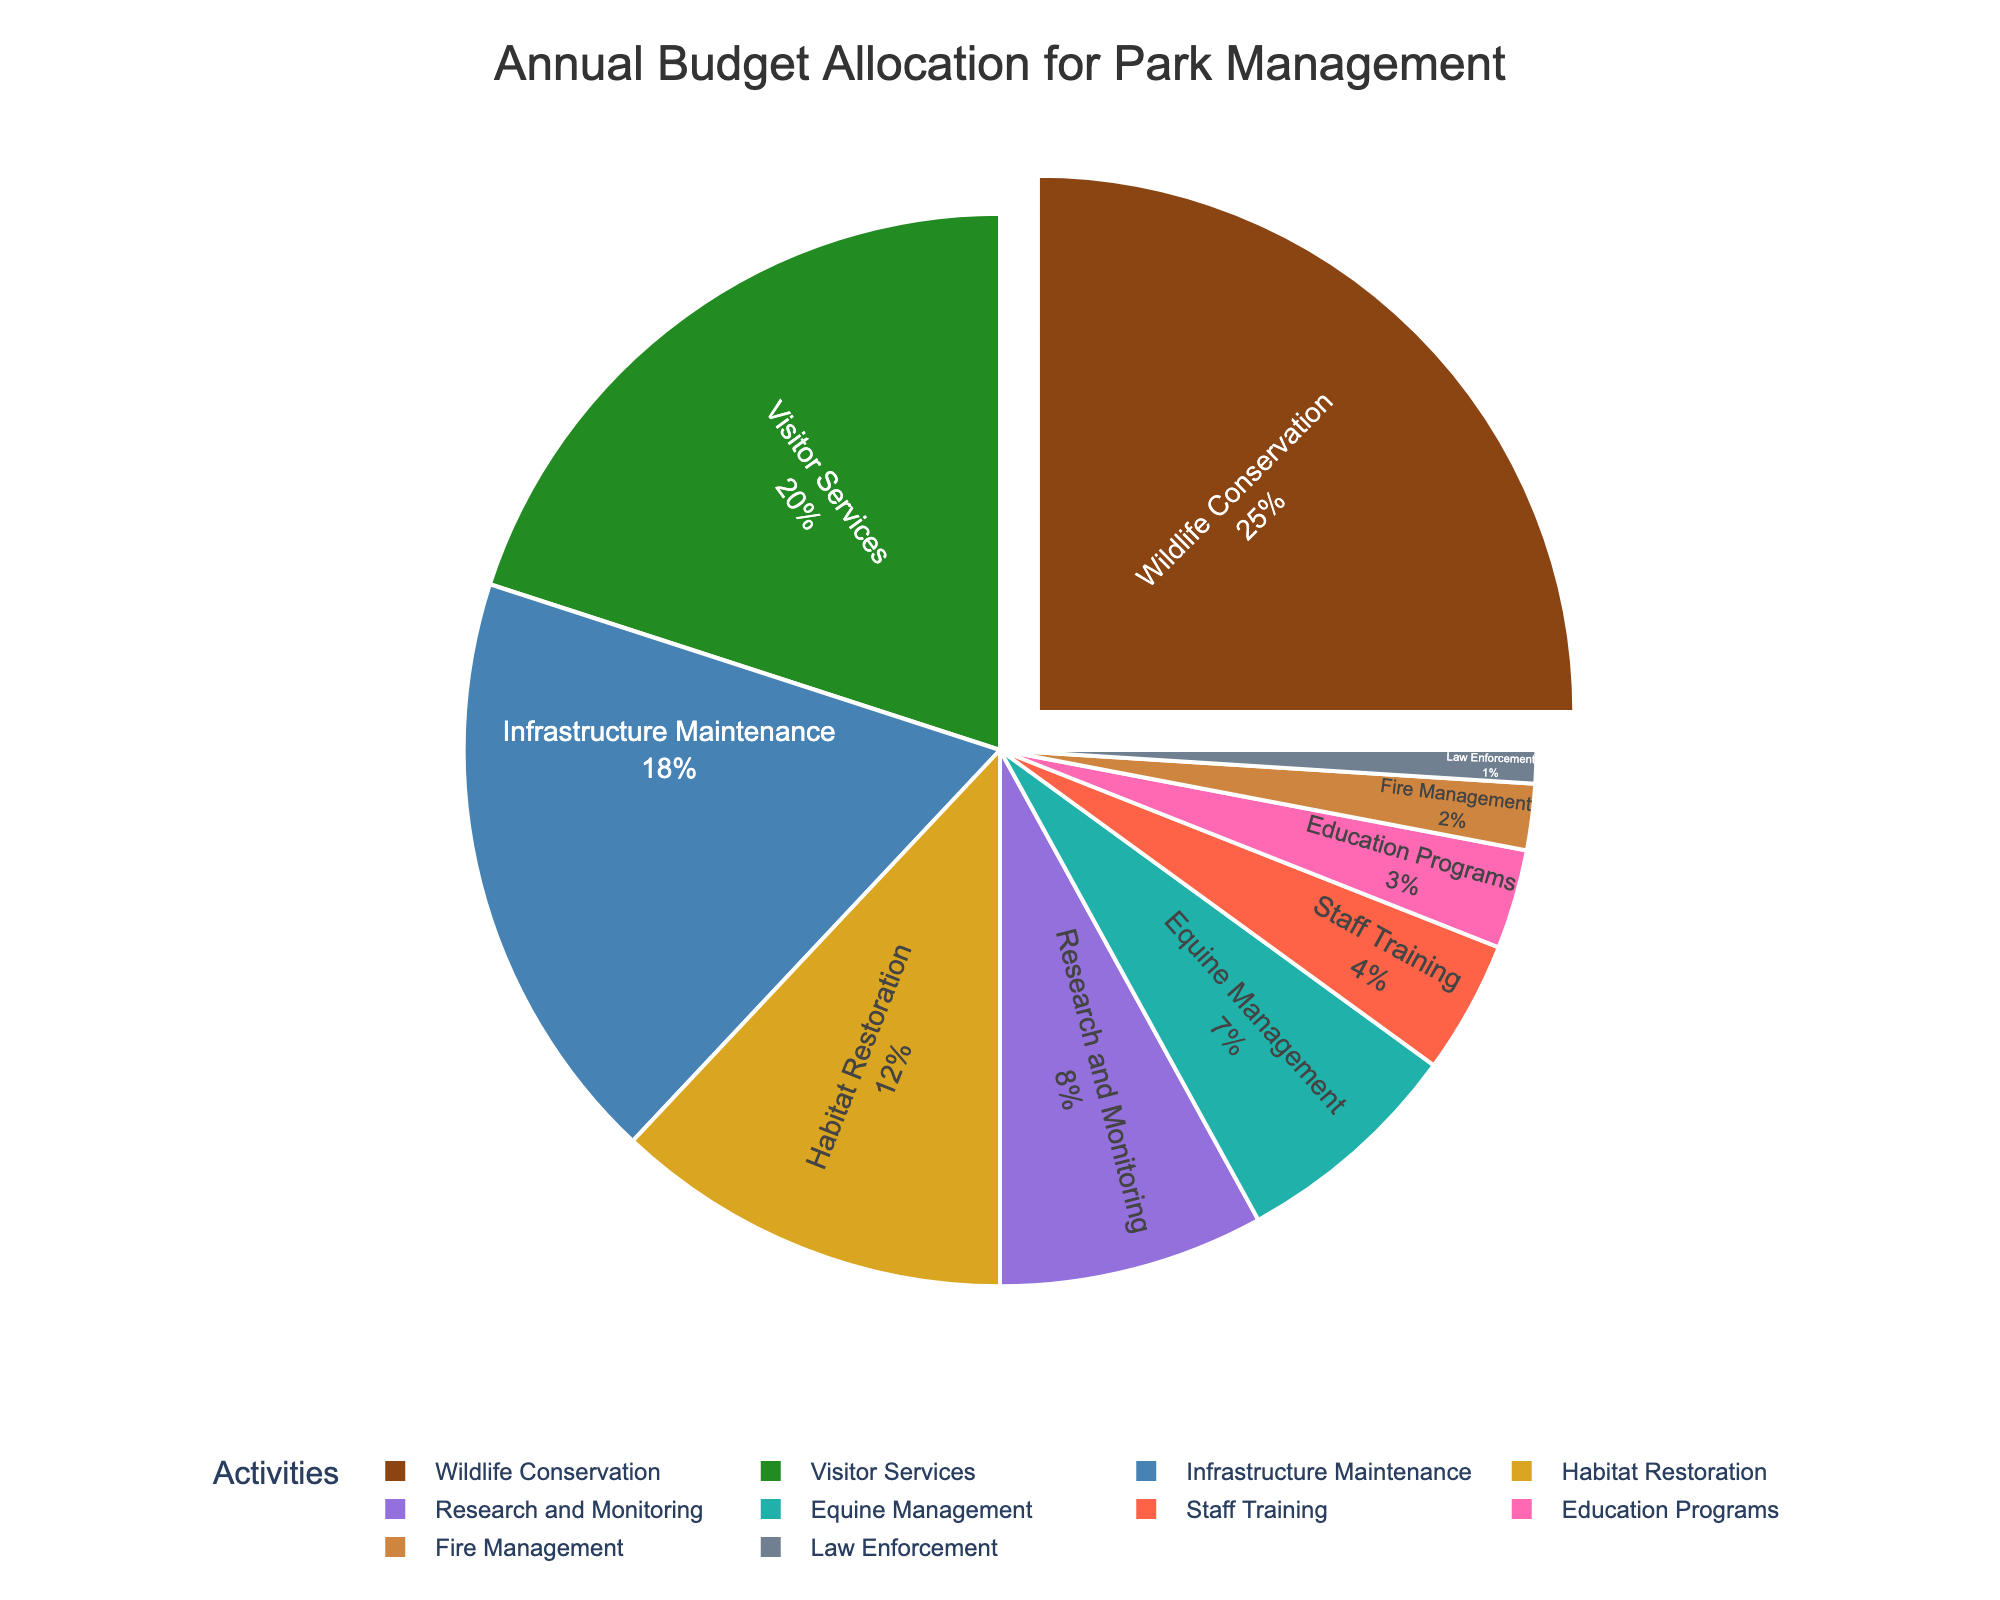What is the highest percentage allocation in the budget? The pie chart indicates that the largest segment represents the activity with the highest budget allocation. By looking at the slices, the largest one is for "Wildlife Conservation." Its label shows 25%, which is higher than any other activity.
Answer: 25% Which two activities have the smallest budget percentages combined? By examining the smaller slices in the pie chart, observe that the smallest are "Law Enforcement" with 1% and "Fire Management" with 2%. Their labels show that adding 1% and 2% yields a combined total of 3%.
Answer: Law Enforcement and Fire Management with a total of 3% How much more is allocated to Wildlife Conservation compared to Education Programs? Find the percentage for Wildlife Conservation (25%) and Education Programs (3%). Subtract the smaller from the larger: 25% - 3% = 22%.
Answer: 22% What percentage of the budget is allocated to activities with individual shares less than or equal to 8%? Identify activities with percentages 8% or less: Law Enforcement (1%), Fire Management (2%), Education Programs (3%), Staff Training (4%), and Research and Monitoring (8%). Add them together: 1% + 2% + 3% + 4% + 8% = 18%.
Answer: 18% Which activity directly follows Equine Management in terms of budget percentage allocation? The pie chart lists the activities in descending order. Equine Management has 7%. The next largest segment is Staff Training with 4%.
Answer: Staff Training What is the difference between the total percentage allocated to Visitor Services and Infrastructure Maintenance? Find the percentages for Visitor Services (20%) and Infrastructure Maintenance (18%). Subtract the smaller from the larger: 20% - 18% = 2%.
Answer: 2% What is the sum of the budget percentages for Habitat Restoration and Research and Monitoring? Identify the percentages for Habitat Restoration (12%) and Research and Monitoring (8%). Add them together: 12% + 8% = 20%.
Answer: 20% What color represents the budget allocation for Visitor Services? The pie chart uses different colors for each activity. Visitor Services is colored dark green in the chart.
Answer: Dark Green 